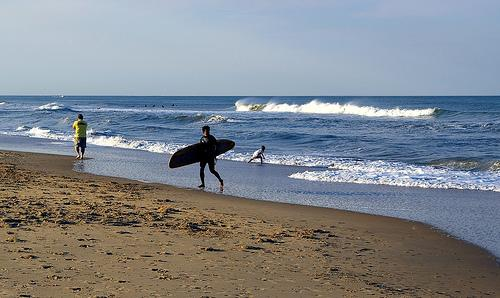Why is the small child in the water?

Choices:
A) enjoys playing
B) is lost
C) cleaning up
D) left home enjoys playing 